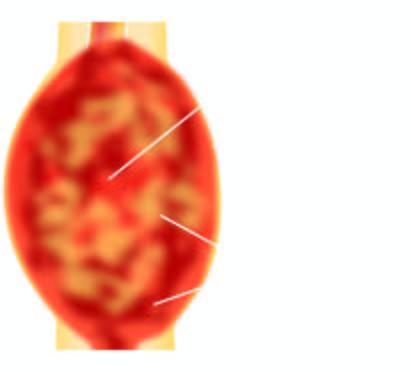what is grey-white, cystic, soft and friable?
Answer the question using a single word or phrase. Cut surface of the tumour 